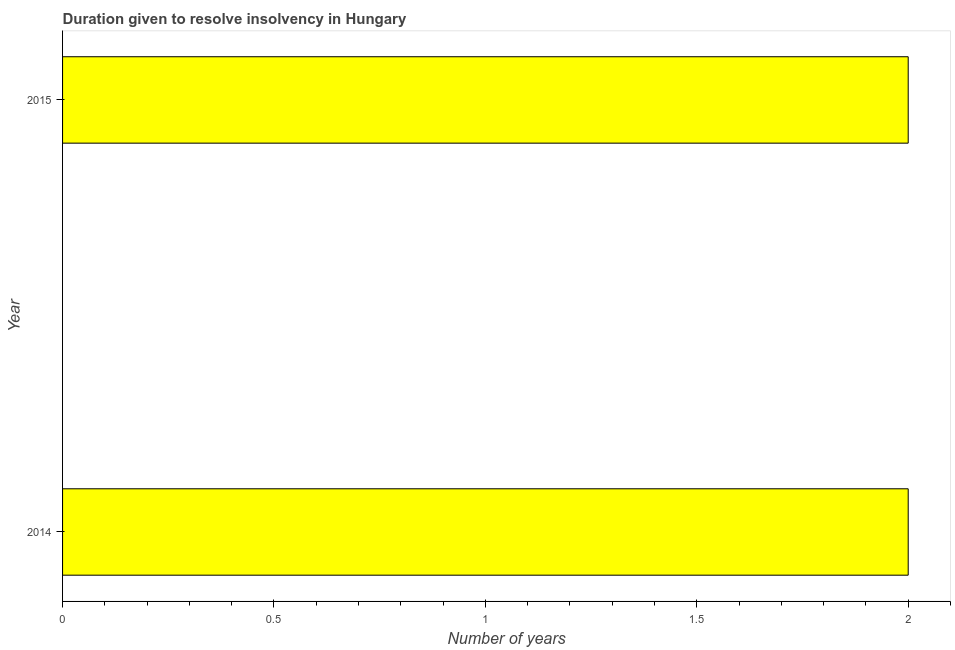Does the graph contain any zero values?
Your answer should be very brief. No. Does the graph contain grids?
Your answer should be very brief. No. What is the title of the graph?
Your response must be concise. Duration given to resolve insolvency in Hungary. What is the label or title of the X-axis?
Your response must be concise. Number of years. Across all years, what is the maximum number of years to resolve insolvency?
Your answer should be compact. 2. Across all years, what is the minimum number of years to resolve insolvency?
Offer a terse response. 2. In which year was the number of years to resolve insolvency maximum?
Give a very brief answer. 2014. In which year was the number of years to resolve insolvency minimum?
Offer a terse response. 2014. What is the sum of the number of years to resolve insolvency?
Your response must be concise. 4. What is the median number of years to resolve insolvency?
Your response must be concise. 2. In how many years, is the number of years to resolve insolvency greater than 1.2 ?
Provide a short and direct response. 2. Are all the bars in the graph horizontal?
Provide a short and direct response. Yes. What is the Number of years in 2015?
Your answer should be compact. 2. 